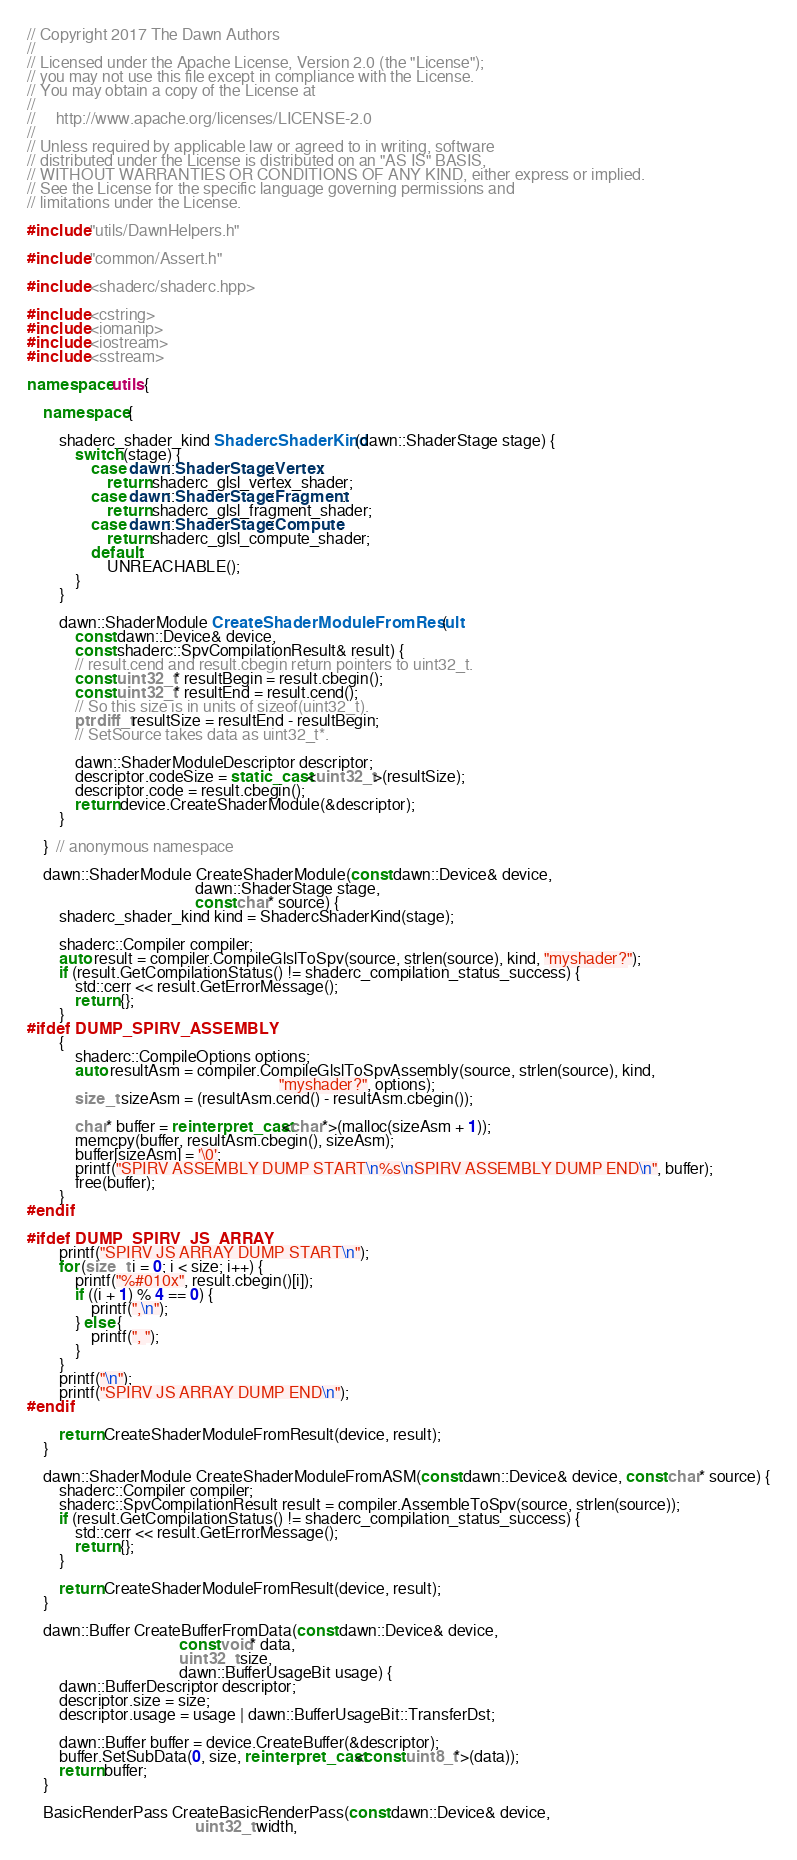Convert code to text. <code><loc_0><loc_0><loc_500><loc_500><_C++_>// Copyright 2017 The Dawn Authors
//
// Licensed under the Apache License, Version 2.0 (the "License");
// you may not use this file except in compliance with the License.
// You may obtain a copy of the License at
//
//     http://www.apache.org/licenses/LICENSE-2.0
//
// Unless required by applicable law or agreed to in writing, software
// distributed under the License is distributed on an "AS IS" BASIS,
// WITHOUT WARRANTIES OR CONDITIONS OF ANY KIND, either express or implied.
// See the License for the specific language governing permissions and
// limitations under the License.

#include "utils/DawnHelpers.h"

#include "common/Assert.h"

#include <shaderc/shaderc.hpp>

#include <cstring>
#include <iomanip>
#include <iostream>
#include <sstream>

namespace utils {

    namespace {

        shaderc_shader_kind ShadercShaderKind(dawn::ShaderStage stage) {
            switch (stage) {
                case dawn::ShaderStage::Vertex:
                    return shaderc_glsl_vertex_shader;
                case dawn::ShaderStage::Fragment:
                    return shaderc_glsl_fragment_shader;
                case dawn::ShaderStage::Compute:
                    return shaderc_glsl_compute_shader;
                default:
                    UNREACHABLE();
            }
        }

        dawn::ShaderModule CreateShaderModuleFromResult(
            const dawn::Device& device,
            const shaderc::SpvCompilationResult& result) {
            // result.cend and result.cbegin return pointers to uint32_t.
            const uint32_t* resultBegin = result.cbegin();
            const uint32_t* resultEnd = result.cend();
            // So this size is in units of sizeof(uint32_t).
            ptrdiff_t resultSize = resultEnd - resultBegin;
            // SetSource takes data as uint32_t*.

            dawn::ShaderModuleDescriptor descriptor;
            descriptor.codeSize = static_cast<uint32_t>(resultSize);
            descriptor.code = result.cbegin();
            return device.CreateShaderModule(&descriptor);
        }

    }  // anonymous namespace

    dawn::ShaderModule CreateShaderModule(const dawn::Device& device,
                                          dawn::ShaderStage stage,
                                          const char* source) {
        shaderc_shader_kind kind = ShadercShaderKind(stage);

        shaderc::Compiler compiler;
        auto result = compiler.CompileGlslToSpv(source, strlen(source), kind, "myshader?");
        if (result.GetCompilationStatus() != shaderc_compilation_status_success) {
            std::cerr << result.GetErrorMessage();
            return {};
        }
#ifdef DUMP_SPIRV_ASSEMBLY
        {
            shaderc::CompileOptions options;
            auto resultAsm = compiler.CompileGlslToSpvAssembly(source, strlen(source), kind,
                                                               "myshader?", options);
            size_t sizeAsm = (resultAsm.cend() - resultAsm.cbegin());

            char* buffer = reinterpret_cast<char*>(malloc(sizeAsm + 1));
            memcpy(buffer, resultAsm.cbegin(), sizeAsm);
            buffer[sizeAsm] = '\0';
            printf("SPIRV ASSEMBLY DUMP START\n%s\nSPIRV ASSEMBLY DUMP END\n", buffer);
            free(buffer);
        }
#endif

#ifdef DUMP_SPIRV_JS_ARRAY
        printf("SPIRV JS ARRAY DUMP START\n");
        for (size_t i = 0; i < size; i++) {
            printf("%#010x", result.cbegin()[i]);
            if ((i + 1) % 4 == 0) {
                printf(",\n");
            } else {
                printf(", ");
            }
        }
        printf("\n");
        printf("SPIRV JS ARRAY DUMP END\n");
#endif

        return CreateShaderModuleFromResult(device, result);
    }

    dawn::ShaderModule CreateShaderModuleFromASM(const dawn::Device& device, const char* source) {
        shaderc::Compiler compiler;
        shaderc::SpvCompilationResult result = compiler.AssembleToSpv(source, strlen(source));
        if (result.GetCompilationStatus() != shaderc_compilation_status_success) {
            std::cerr << result.GetErrorMessage();
            return {};
        }

        return CreateShaderModuleFromResult(device, result);
    }

    dawn::Buffer CreateBufferFromData(const dawn::Device& device,
                                      const void* data,
                                      uint32_t size,
                                      dawn::BufferUsageBit usage) {
        dawn::BufferDescriptor descriptor;
        descriptor.size = size;
        descriptor.usage = usage | dawn::BufferUsageBit::TransferDst;

        dawn::Buffer buffer = device.CreateBuffer(&descriptor);
        buffer.SetSubData(0, size, reinterpret_cast<const uint8_t*>(data));
        return buffer;
    }

    BasicRenderPass CreateBasicRenderPass(const dawn::Device& device,
                                          uint32_t width,</code> 